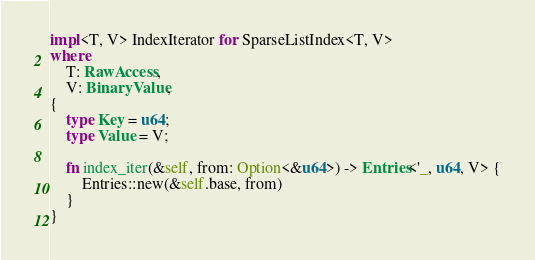<code> <loc_0><loc_0><loc_500><loc_500><_Rust_>
impl<T, V> IndexIterator for SparseListIndex<T, V>
where
    T: RawAccess,
    V: BinaryValue,
{
    type Key = u64;
    type Value = V;

    fn index_iter(&self, from: Option<&u64>) -> Entries<'_, u64, V> {
        Entries::new(&self.base, from)
    }
}
</code> 